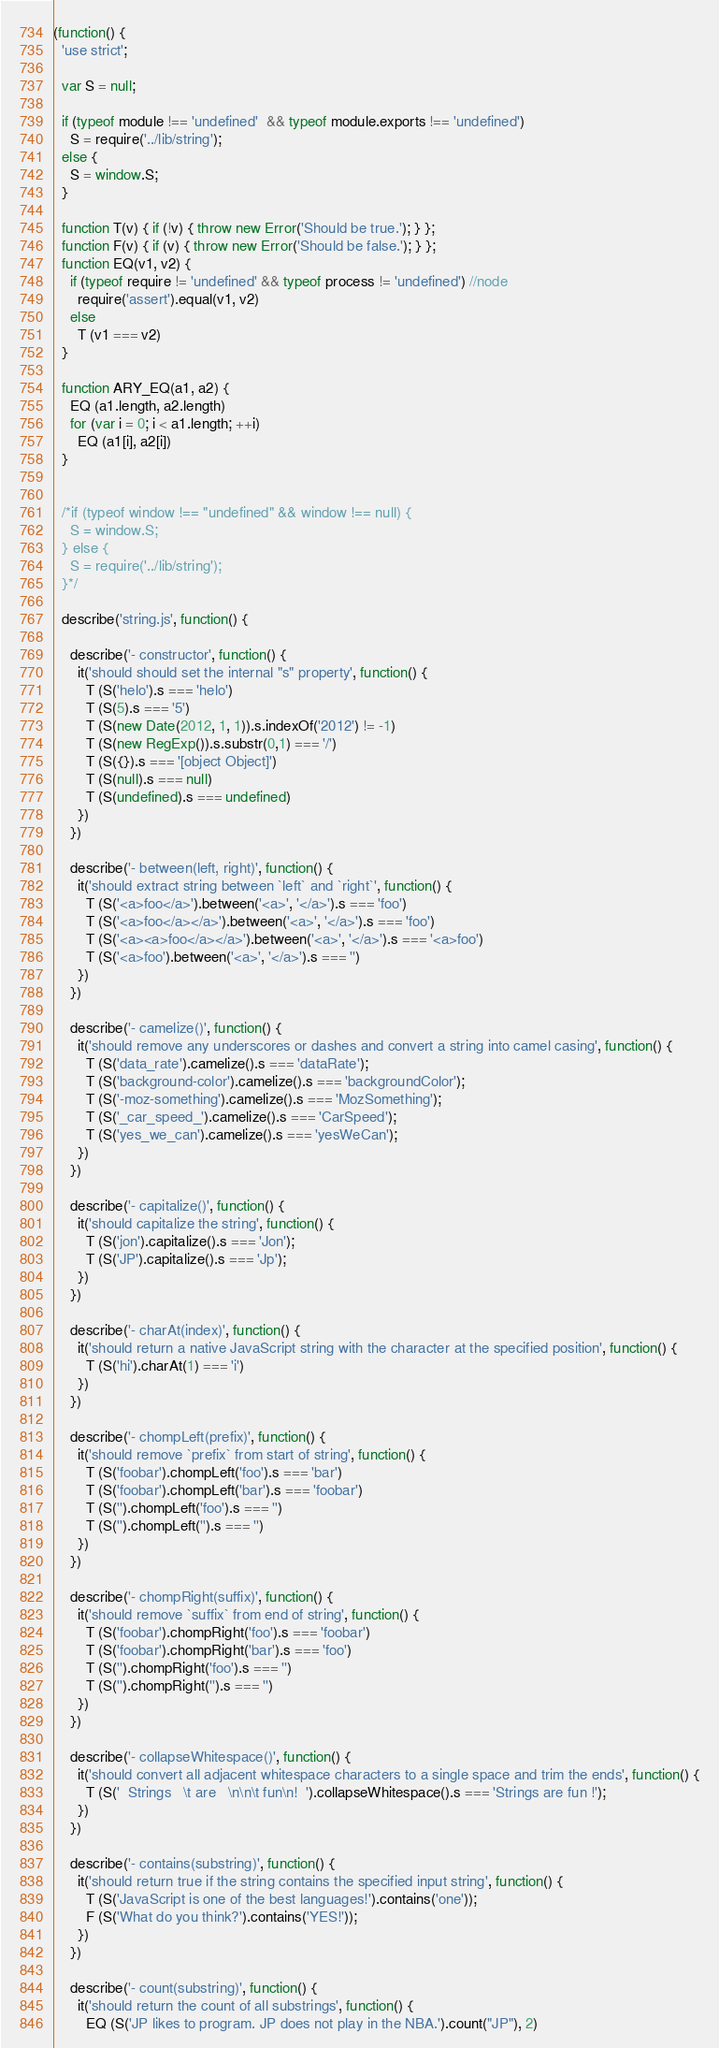Convert code to text. <code><loc_0><loc_0><loc_500><loc_500><_JavaScript_>(function() {
  'use strict';

  var S = null;

  if (typeof module !== 'undefined'  && typeof module.exports !== 'undefined')
    S = require('../lib/string');
  else {
    S = window.S;
  }

  function T(v) { if (!v) { throw new Error('Should be true.'); } };
  function F(v) { if (v) { throw new Error('Should be false.'); } };
  function EQ(v1, v2) {
    if (typeof require != 'undefined' && typeof process != 'undefined') //node
      require('assert').equal(v1, v2)
    else
      T (v1 === v2)
  }

  function ARY_EQ(a1, a2) {
    EQ (a1.length, a2.length)
    for (var i = 0; i < a1.length; ++i)
      EQ (a1[i], a2[i])
  }


  /*if (typeof window !== "undefined" && window !== null) {
    S = window.S;
  } else {
    S = require('../lib/string');
  }*/

  describe('string.js', function() {

    describe('- constructor', function() {
      it('should should set the internal "s" property', function() {
        T (S('helo').s === 'helo')
        T (S(5).s === '5')
        T (S(new Date(2012, 1, 1)).s.indexOf('2012') != -1)
        T (S(new RegExp()).s.substr(0,1) === '/')
        T (S({}).s === '[object Object]')
        T (S(null).s === null)
        T (S(undefined).s === undefined)
      })
    })

    describe('- between(left, right)', function() {
      it('should extract string between `left` and `right`', function() {
        T (S('<a>foo</a>').between('<a>', '</a>').s === 'foo')
        T (S('<a>foo</a></a>').between('<a>', '</a>').s === 'foo')
        T (S('<a><a>foo</a></a>').between('<a>', '</a>').s === '<a>foo')
        T (S('<a>foo').between('<a>', '</a>').s === '')
      })
    })

    describe('- camelize()', function() {
      it('should remove any underscores or dashes and convert a string into camel casing', function() {
        T (S('data_rate').camelize().s === 'dataRate');
        T (S('background-color').camelize().s === 'backgroundColor');
        T (S('-moz-something').camelize().s === 'MozSomething');
        T (S('_car_speed_').camelize().s === 'CarSpeed');
        T (S('yes_we_can').camelize().s === 'yesWeCan');
      })
    })

    describe('- capitalize()', function() {
      it('should capitalize the string', function() {
        T (S('jon').capitalize().s === 'Jon');
        T (S('JP').capitalize().s === 'Jp');
      })
    })

    describe('- charAt(index)', function() {
      it('should return a native JavaScript string with the character at the specified position', function() {
        T (S('hi').charAt(1) === 'i')
      })
    })

    describe('- chompLeft(prefix)', function() {
      it('should remove `prefix` from start of string', function() {
        T (S('foobar').chompLeft('foo').s === 'bar')
        T (S('foobar').chompLeft('bar').s === 'foobar')
        T (S('').chompLeft('foo').s === '')
        T (S('').chompLeft('').s === '')
      })
    })

    describe('- chompRight(suffix)', function() {
      it('should remove `suffix` from end of string', function() {
        T (S('foobar').chompRight('foo').s === 'foobar')
        T (S('foobar').chompRight('bar').s === 'foo')
        T (S('').chompRight('foo').s === '')
        T (S('').chompRight('').s === '')
      })
    })

    describe('- collapseWhitespace()', function() {
      it('should convert all adjacent whitespace characters to a single space and trim the ends', function() {
        T (S('  Strings   \t are   \n\n\t fun\n!  ').collapseWhitespace().s === 'Strings are fun !');
      })
    })

    describe('- contains(substring)', function() {
      it('should return true if the string contains the specified input string', function() {
        T (S('JavaScript is one of the best languages!').contains('one'));
        F (S('What do you think?').contains('YES!'));
      })
    })

    describe('- count(substring)', function() {
      it('should return the count of all substrings', function() {
        EQ (S('JP likes to program. JP does not play in the NBA.').count("JP"), 2)</code> 